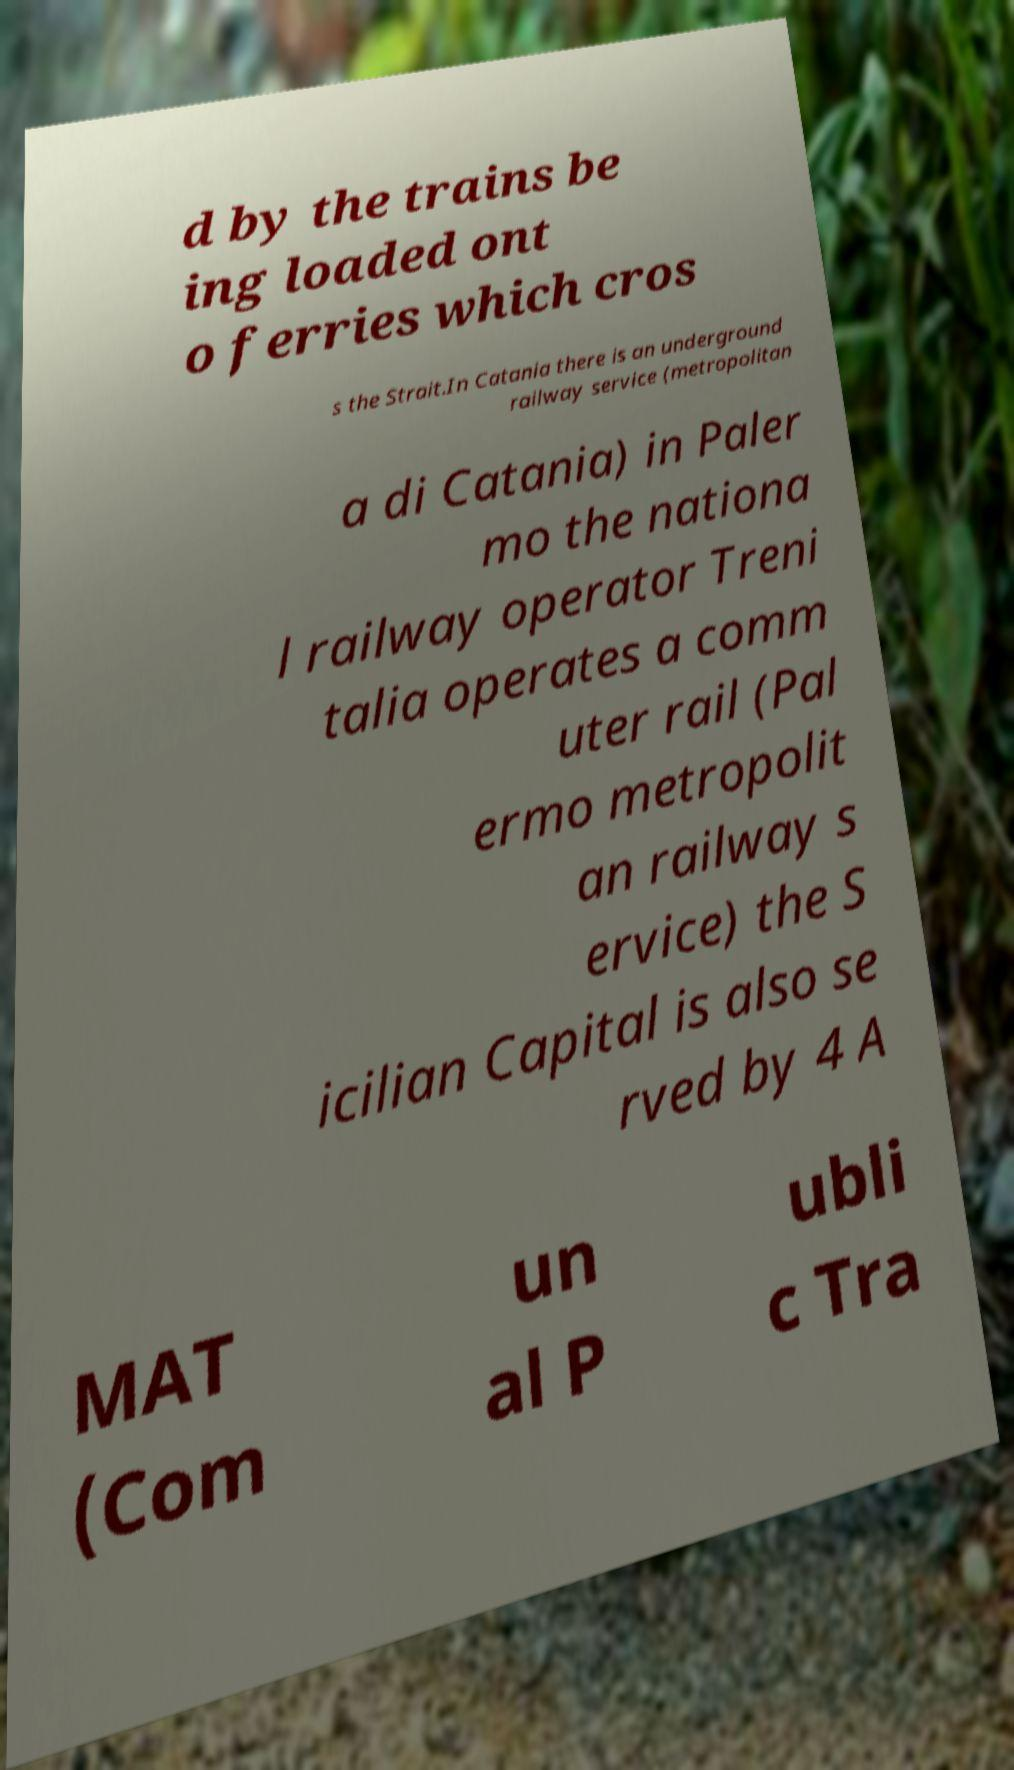Can you read and provide the text displayed in the image?This photo seems to have some interesting text. Can you extract and type it out for me? d by the trains be ing loaded ont o ferries which cros s the Strait.In Catania there is an underground railway service (metropolitan a di Catania) in Paler mo the nationa l railway operator Treni talia operates a comm uter rail (Pal ermo metropolit an railway s ervice) the S icilian Capital is also se rved by 4 A MAT (Com un al P ubli c Tra 